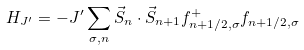<formula> <loc_0><loc_0><loc_500><loc_500>H _ { J ^ { \prime } } = - J ^ { \prime } \sum _ { \sigma , n } { \vec { S } } _ { n } \cdot { \vec { S } } _ { n + 1 } f _ { n + 1 / 2 , \sigma } ^ { + } f _ { n + 1 / 2 , \sigma }</formula> 